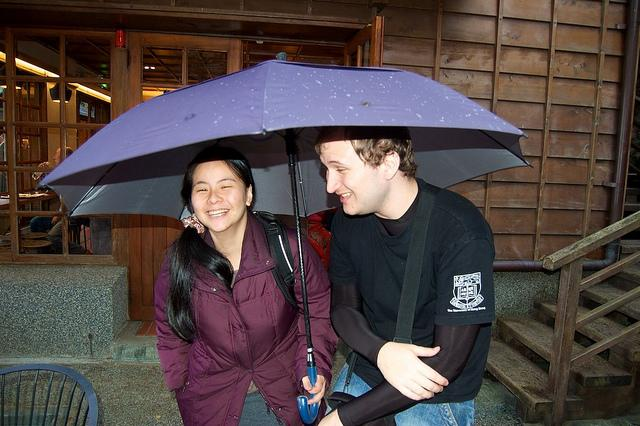What is starting here? rain 